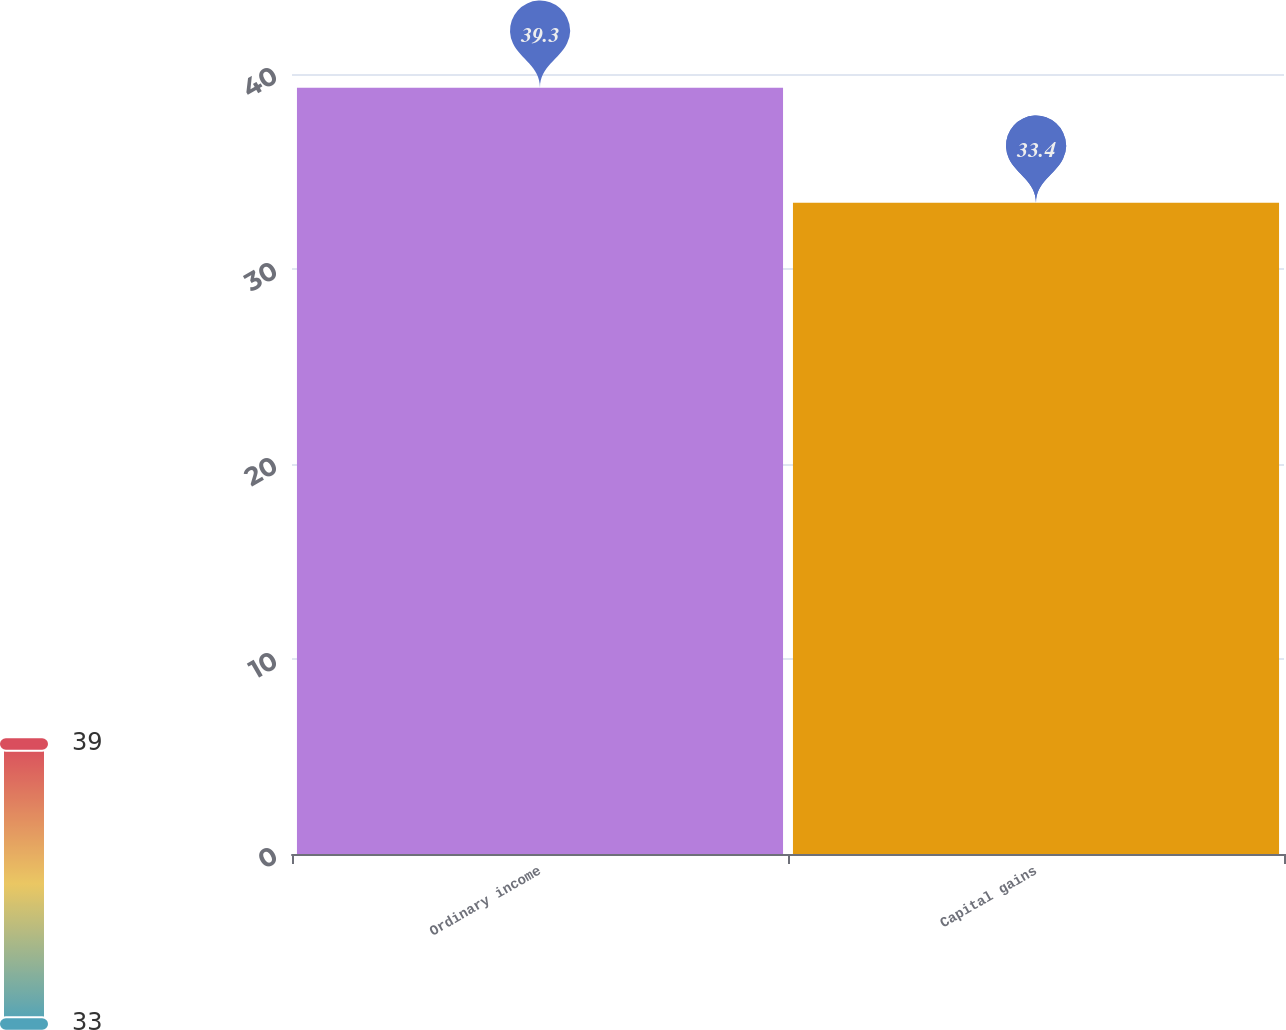<chart> <loc_0><loc_0><loc_500><loc_500><bar_chart><fcel>Ordinary income<fcel>Capital gains<nl><fcel>39.3<fcel>33.4<nl></chart> 